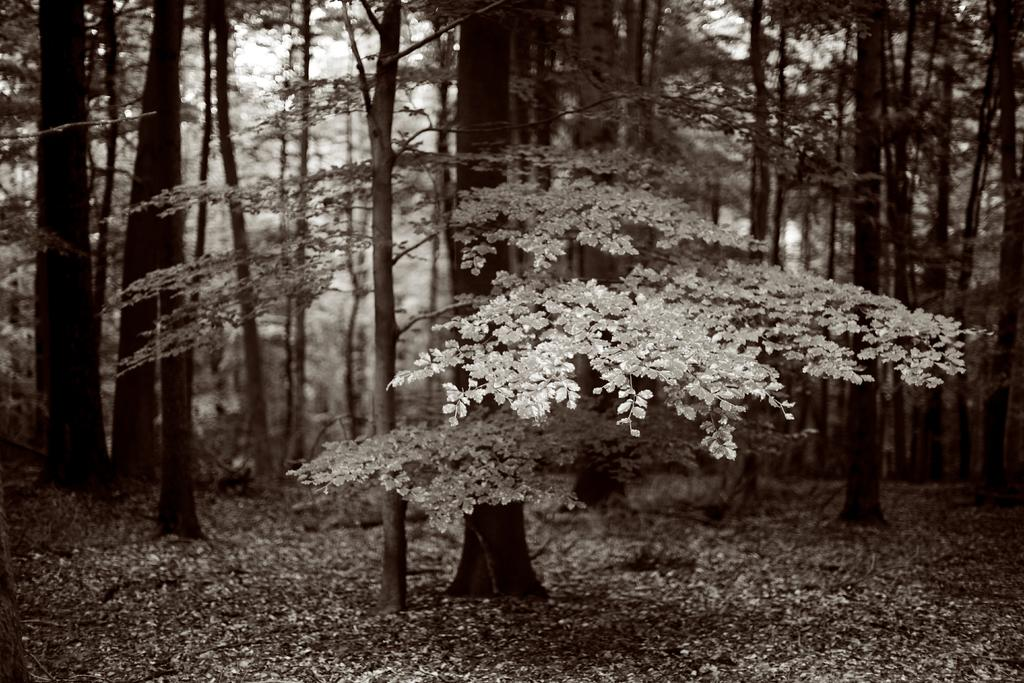What type of vegetation is present in the image? There are plants with leaves in the image. Where are the plants located? The plants are on the ground. Can you describe the background of the image? The background of the image is blurred. What type of juice is being squeezed from the sock in the image? There is no sock or juice present in the image; it only features plants with leaves on the ground and a blurred background. 